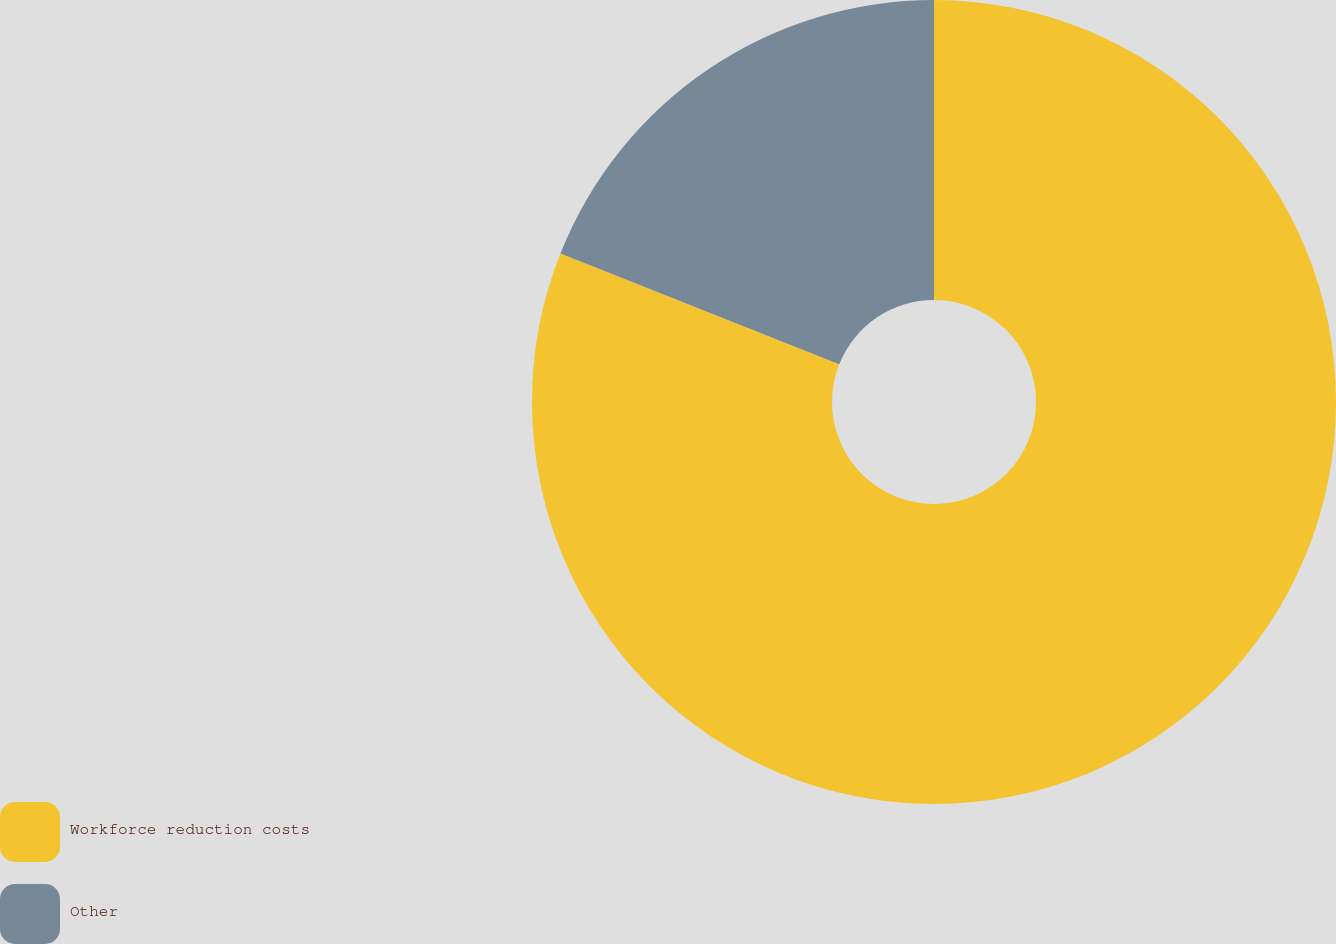Convert chart. <chart><loc_0><loc_0><loc_500><loc_500><pie_chart><fcel>Workforce reduction costs<fcel>Other<nl><fcel>81.02%<fcel>18.98%<nl></chart> 